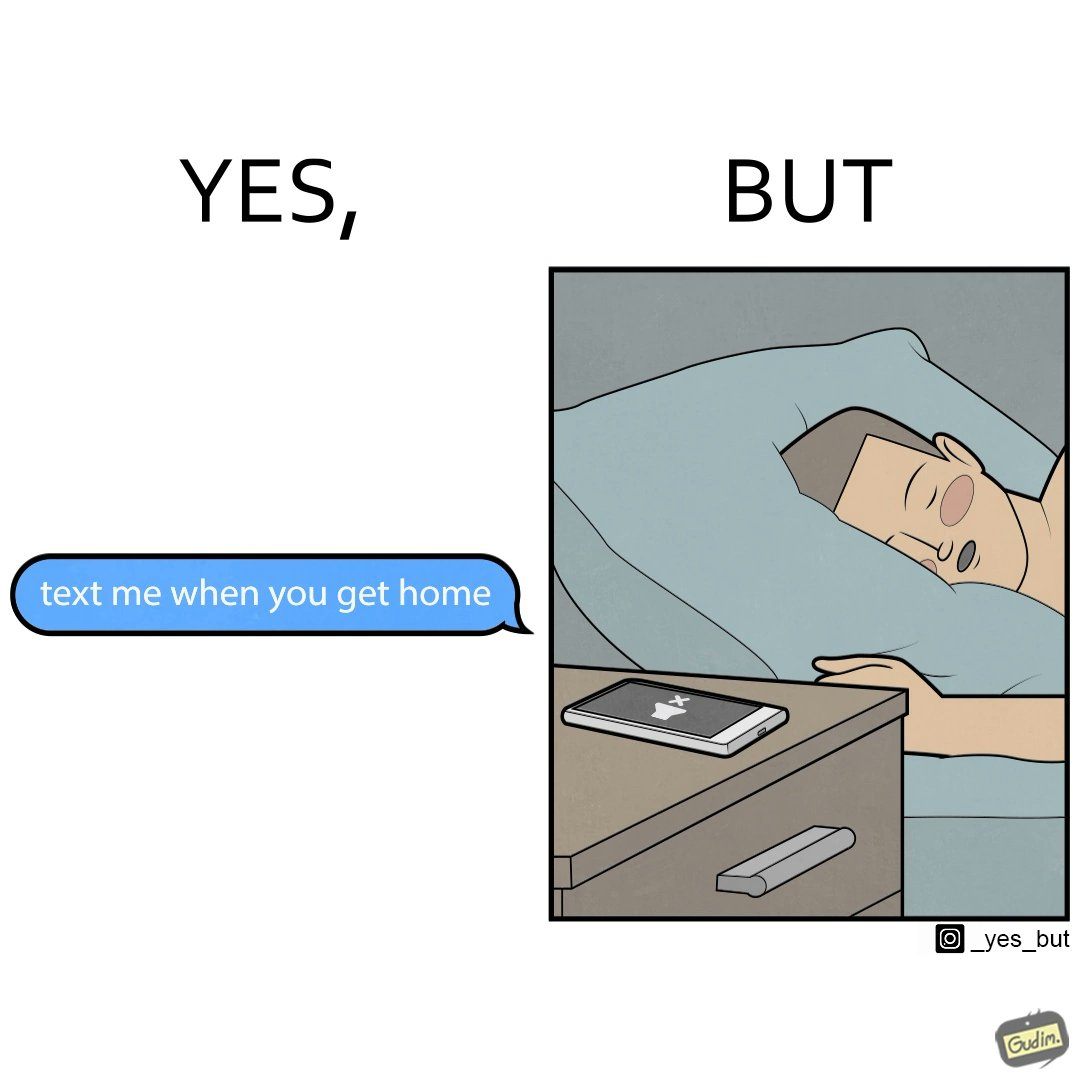Explain why this image is satirical. The images are funny since they show how a sender wants the recipient to revert once he gets back home but the tired recipient ends up falling asleep completely forgetting about the message while the sender keeps waiting for a reply. The fact that the recipient leaves his phone on silent mode makes it even funnier since the probability of the sender being able to contact him becomes even slimmer. 